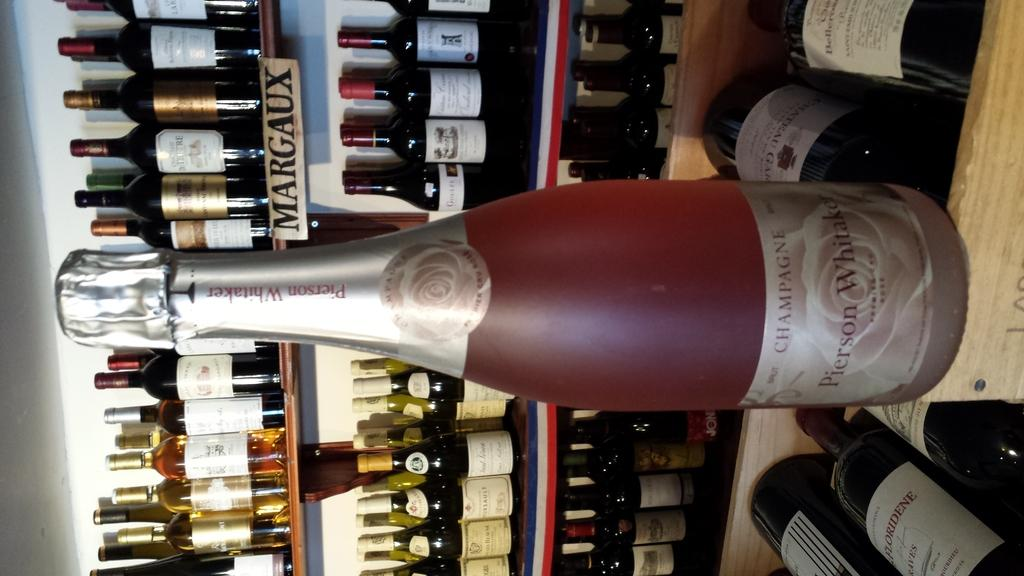<image>
Provide a brief description of the given image. A bottle of champagne with a reddish color to it. 